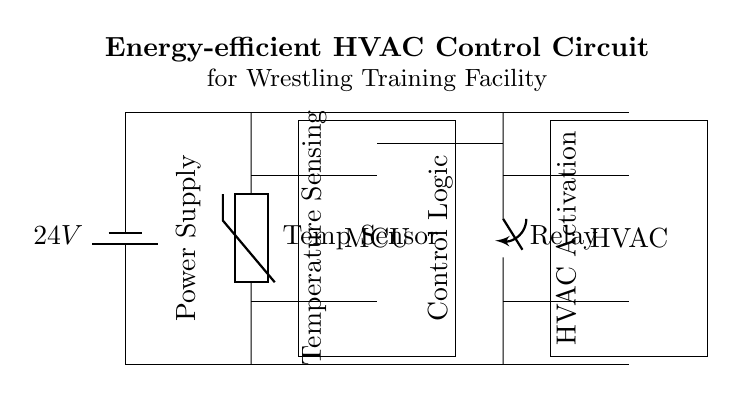What type of power supply is used in this circuit? The circuit diagram shows a battery labeled as a power supply, specifically a 24V battery. This indicates that the power supply type is a DC battery.
Answer: 24V battery What component is used to sense temperature? The diagram includes a thermistor labeled as a temperature sensor. The thermistor is a type of temperature-sensitive resistor commonly used for sensing temperature changes.
Answer: Thermistor What device controls the HVAC system? The microcontroller, shown as a rectangular box labeled MCU, is responsible for processing the input from the temperature sensor and controlling the relay that activates the HVAC system.
Answer: Microcontroller How many main components are connected to the relay? The relay connects to two main components: the microcontroller (MCU) and the HVAC system. The circuit diagram shows lines connecting these components to the relay.
Answer: Two What is the primary purpose of this circuit? The circuit's title states it's an energy-efficient HVAC control circuit designed to maintain an optimal temperature in a wrestling training facility, indicating its primary purpose is temperature control.
Answer: Temperature control What connections can be considered power connections in this circuit? The circuit features connections from the 24V battery running from the power supply to both the thermistor and the relay, which provide the circuit with necessary power for operation.
Answer: From battery to components What is the control signal type for the HVAC system? The control signal for activating the HVAC is typically digital, coming from the microcontroller through the relay, indicating the HVAC's operational status based on temperature readings.
Answer: Digital signal 